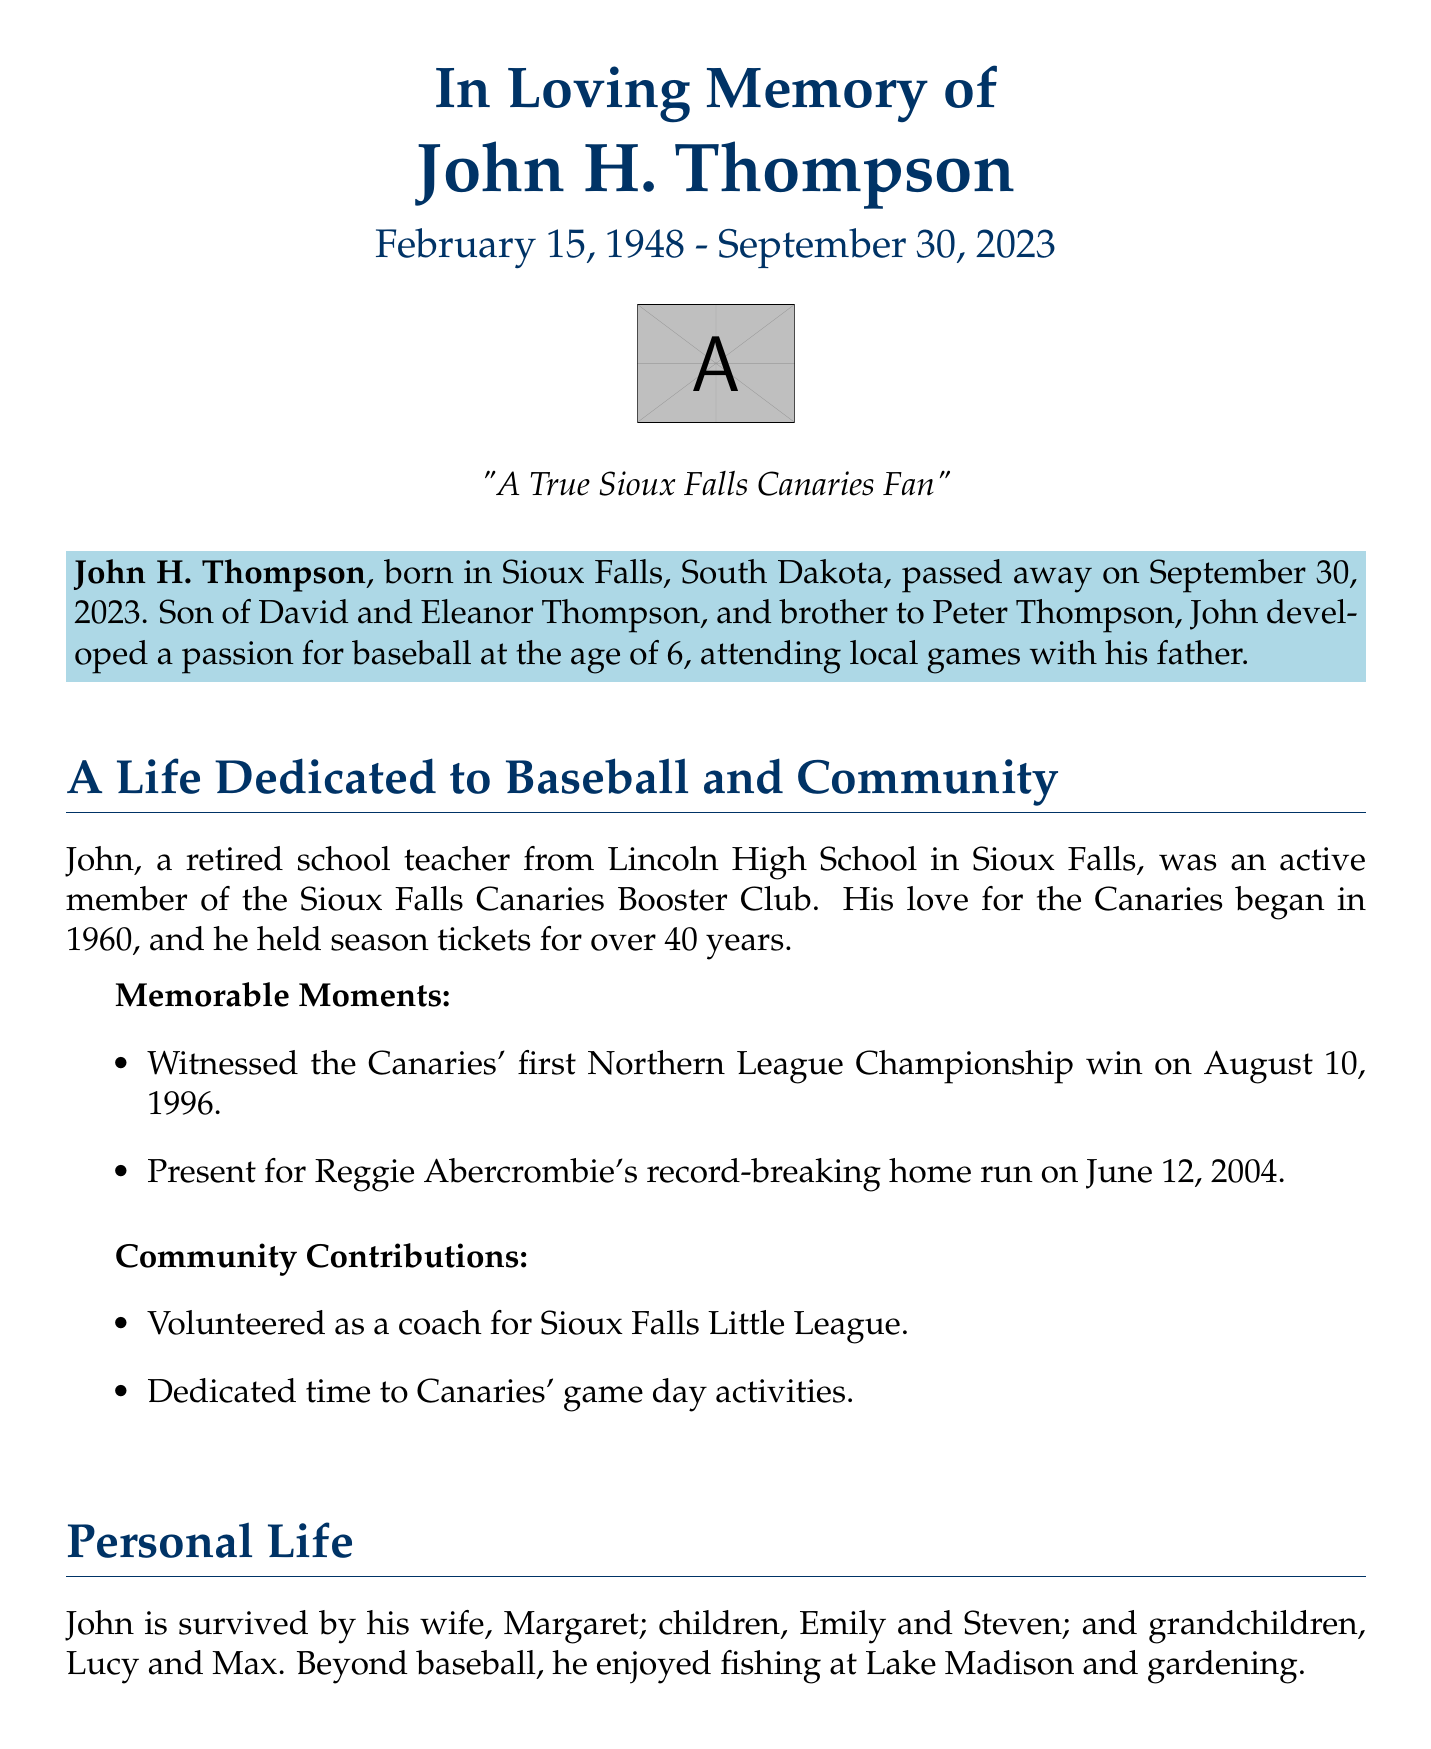What is the full name of the individual honored in the obituary? The document states the individual's full name at the beginning, which is John H. Thompson.
Answer: John H. Thompson When was John H. Thompson born? The obituary provides the birth date in the introductory section, which is February 15, 1948.
Answer: February 15, 1948 What was the date of John's death? The document mentions the date of John's passing, which is September 30, 2023.
Answer: September 30, 2023 How many years did John hold season tickets for the Canaries? The obituary notes that he held season tickets for over 40 years.
Answer: Over 40 years What memorable event did John witness on August 10, 1996? The document lists the first Northern League Championship win for the Canaries as a notable event John attended.
Answer: First Northern League Championship win Who survived John? The obituary lists his immediate family, including his wife, Margaret.
Answer: Margaret What contribution did John make to the Sioux Falls Little League? The document states that John volunteered as a coach.
Answer: Volunteered as a coach When is the memorial service scheduled? The obituary provides the date of the memorial service mentioned in the services section, which is October 5, 2023.
Answer: October 5, 2023 What is stated about John's relationship with the Sioux Falls community? The obituary reflects on John's impact on the community and states he had unwavering support for local baseball.
Answer: Unwavering support for local baseball 